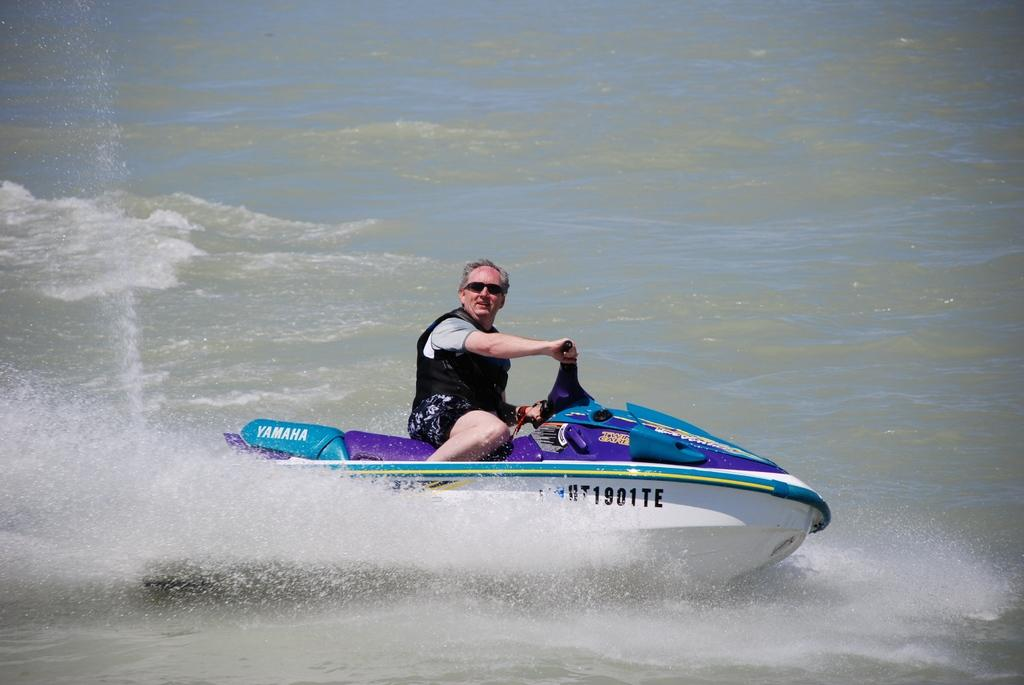Who is in the image? There is a person in the image. What is the person doing in the image? The person is sitting on a water bike. Where is the water bike located? The water bike is on a river. What type of shoes is the person wearing while riding the water bike? There is no information about the person's shoes in the image, so we cannot determine what type of shoes they are wearing. 